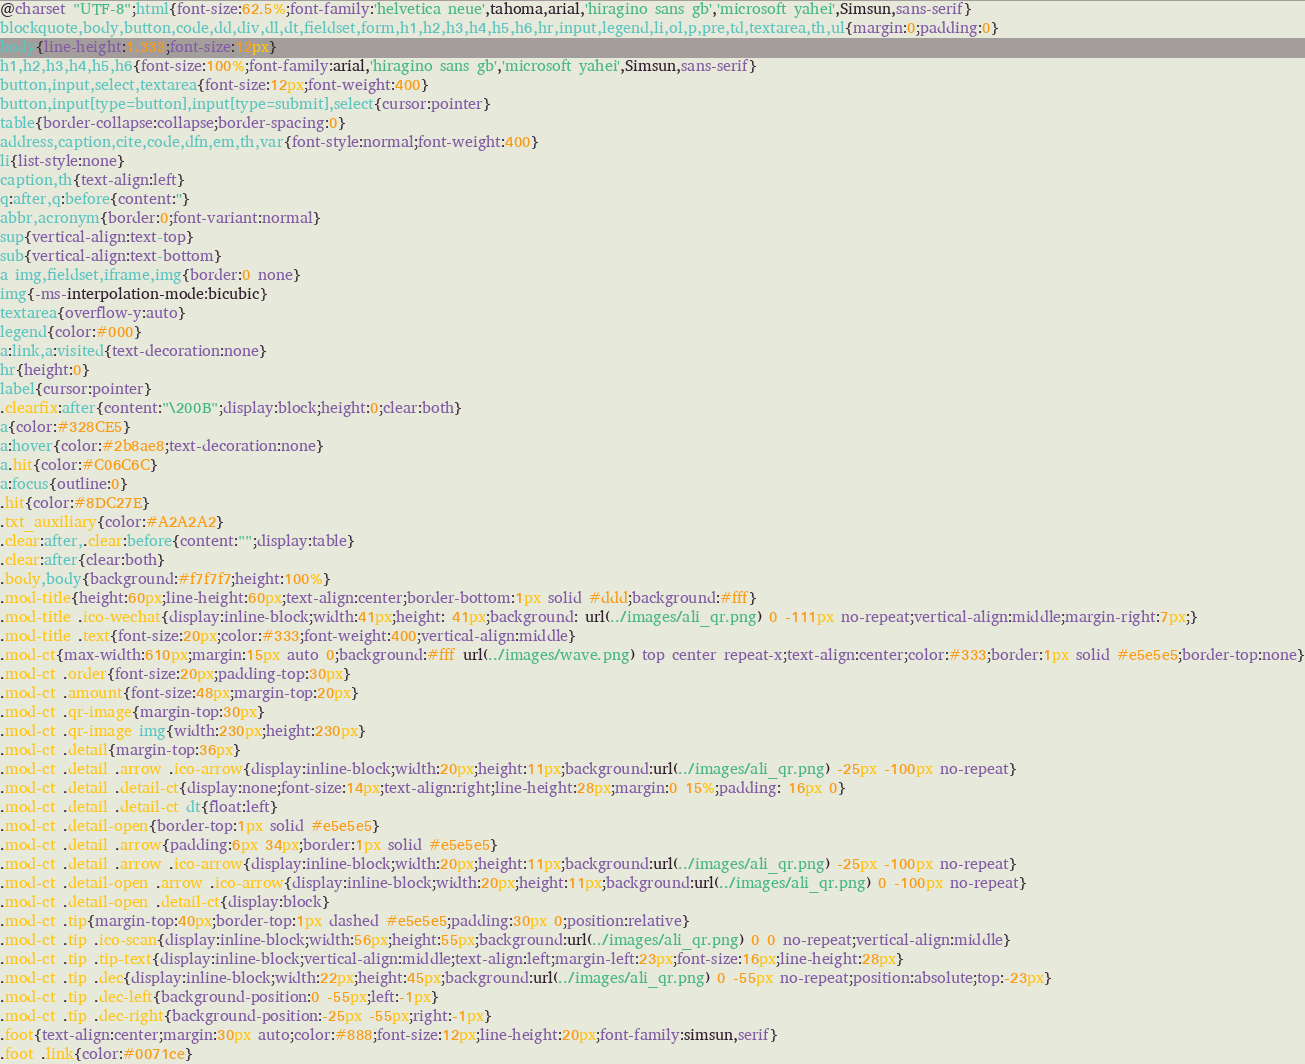<code> <loc_0><loc_0><loc_500><loc_500><_CSS_>@charset "UTF-8";html{font-size:62.5%;font-family:'helvetica neue',tahoma,arial,'hiragino sans gb','microsoft yahei',Simsun,sans-serif}
blockquote,body,button,code,dd,div,dl,dt,fieldset,form,h1,h2,h3,h4,h5,h6,hr,input,legend,li,ol,p,pre,td,textarea,th,ul{margin:0;padding:0}
body{line-height:1.333;font-size:12px}
h1,h2,h3,h4,h5,h6{font-size:100%;font-family:arial,'hiragino sans gb','microsoft yahei',Simsun,sans-serif}
button,input,select,textarea{font-size:12px;font-weight:400}
button,input[type=button],input[type=submit],select{cursor:pointer}
table{border-collapse:collapse;border-spacing:0}
address,caption,cite,code,dfn,em,th,var{font-style:normal;font-weight:400}
li{list-style:none}
caption,th{text-align:left}
q:after,q:before{content:''}
abbr,acronym{border:0;font-variant:normal}
sup{vertical-align:text-top}
sub{vertical-align:text-bottom}
a img,fieldset,iframe,img{border:0 none}
img{-ms-interpolation-mode:bicubic}
textarea{overflow-y:auto}
legend{color:#000}
a:link,a:visited{text-decoration:none}
hr{height:0}
label{cursor:pointer}
.clearfix:after{content:"\200B";display:block;height:0;clear:both}
a{color:#328CE5}
a:hover{color:#2b8ae8;text-decoration:none}
a.hit{color:#C06C6C}
a:focus{outline:0}
.hit{color:#8DC27E}
.txt_auxiliary{color:#A2A2A2}
.clear:after,.clear:before{content:"";display:table}
.clear:after{clear:both}
.body,body{background:#f7f7f7;height:100%}
.mod-title{height:60px;line-height:60px;text-align:center;border-bottom:1px solid #ddd;background:#fff}
.mod-title .ico-wechat{display:inline-block;width:41px;height: 41px;background: url(../images/ali_qr.png) 0 -111px no-repeat;vertical-align:middle;margin-right:7px;}
.mod-title .text{font-size:20px;color:#333;font-weight:400;vertical-align:middle}
.mod-ct{max-width:610px;margin:15px auto 0;background:#fff url(../images/wave.png) top center repeat-x;text-align:center;color:#333;border:1px solid #e5e5e5;border-top:none}
.mod-ct .order{font-size:20px;padding-top:30px}
.mod-ct .amount{font-size:48px;margin-top:20px}
.mod-ct .qr-image{margin-top:30px}
.mod-ct .qr-image img{width:230px;height:230px}
.mod-ct .detail{margin-top:36px}
.mod-ct .detail .arrow .ico-arrow{display:inline-block;width:20px;height:11px;background:url(../images/ali_qr.png) -25px -100px no-repeat}
.mod-ct .detail .detail-ct{display:none;font-size:14px;text-align:right;line-height:28px;margin:0 15%;padding: 16px 0}
.mod-ct .detail .detail-ct dt{float:left}
.mod-ct .detail-open{border-top:1px solid #e5e5e5}
.mod-ct .detail .arrow{padding:6px 34px;border:1px solid #e5e5e5}
.mod-ct .detail .arrow .ico-arrow{display:inline-block;width:20px;height:11px;background:url(../images/ali_qr.png) -25px -100px no-repeat}
.mod-ct .detail-open .arrow .ico-arrow{display:inline-block;width:20px;height:11px;background:url(../images/ali_qr.png) 0 -100px no-repeat}
.mod-ct .detail-open .detail-ct{display:block}
.mod-ct .tip{margin-top:40px;border-top:1px dashed #e5e5e5;padding:30px 0;position:relative}
.mod-ct .tip .ico-scan{display:inline-block;width:56px;height:55px;background:url(../images/ali_qr.png) 0 0 no-repeat;vertical-align:middle}
.mod-ct .tip .tip-text{display:inline-block;vertical-align:middle;text-align:left;margin-left:23px;font-size:16px;line-height:28px}
.mod-ct .tip .dec{display:inline-block;width:22px;height:45px;background:url(../images/ali_qr.png) 0 -55px no-repeat;position:absolute;top:-23px}
.mod-ct .tip .dec-left{background-position:0 -55px;left:-1px}
.mod-ct .tip .dec-right{background-position:-25px -55px;right:-1px}
.foot{text-align:center;margin:30px auto;color:#888;font-size:12px;line-height:20px;font-family:simsun,serif}
.foot .link{color:#0071ce}
</code> 